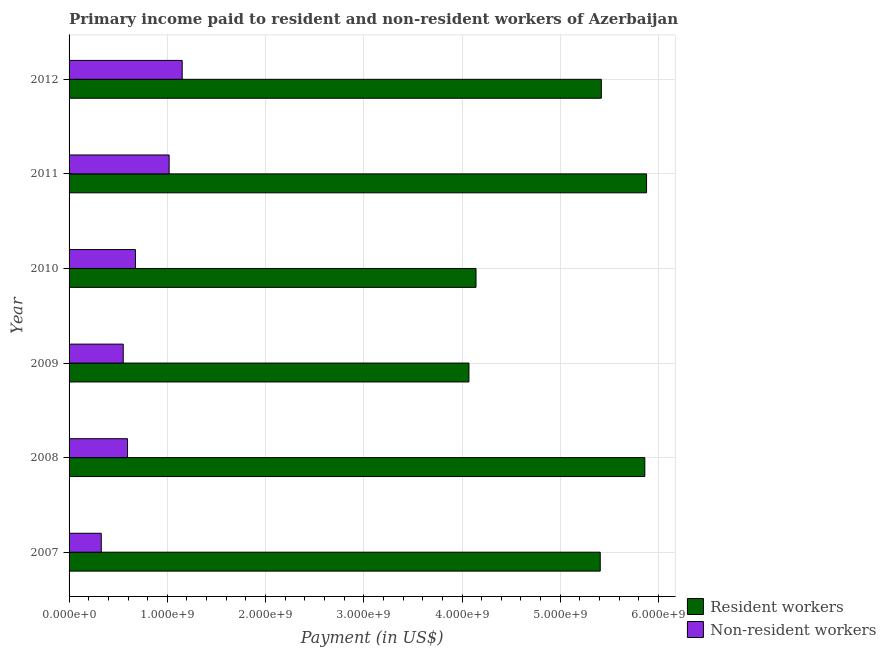How many different coloured bars are there?
Your response must be concise. 2. How many groups of bars are there?
Provide a short and direct response. 6. Are the number of bars per tick equal to the number of legend labels?
Give a very brief answer. Yes. How many bars are there on the 6th tick from the top?
Your answer should be compact. 2. How many bars are there on the 4th tick from the bottom?
Your answer should be very brief. 2. What is the label of the 6th group of bars from the top?
Keep it short and to the point. 2007. What is the payment made to resident workers in 2011?
Offer a terse response. 5.88e+09. Across all years, what is the maximum payment made to non-resident workers?
Keep it short and to the point. 1.15e+09. Across all years, what is the minimum payment made to resident workers?
Make the answer very short. 4.07e+09. In which year was the payment made to non-resident workers maximum?
Offer a very short reply. 2012. What is the total payment made to non-resident workers in the graph?
Give a very brief answer. 4.32e+09. What is the difference between the payment made to non-resident workers in 2008 and that in 2009?
Keep it short and to the point. 4.37e+07. What is the difference between the payment made to non-resident workers in 2009 and the payment made to resident workers in 2008?
Ensure brevity in your answer.  -5.31e+09. What is the average payment made to non-resident workers per year?
Provide a succinct answer. 7.20e+08. In the year 2007, what is the difference between the payment made to non-resident workers and payment made to resident workers?
Provide a short and direct response. -5.08e+09. What is the ratio of the payment made to resident workers in 2009 to that in 2012?
Offer a terse response. 0.75. What is the difference between the highest and the second highest payment made to resident workers?
Keep it short and to the point. 1.74e+07. What is the difference between the highest and the lowest payment made to non-resident workers?
Your answer should be compact. 8.24e+08. What does the 1st bar from the top in 2012 represents?
Give a very brief answer. Non-resident workers. What does the 2nd bar from the bottom in 2009 represents?
Offer a very short reply. Non-resident workers. Are all the bars in the graph horizontal?
Your response must be concise. Yes. What is the difference between two consecutive major ticks on the X-axis?
Your answer should be very brief. 1.00e+09. Are the values on the major ticks of X-axis written in scientific E-notation?
Ensure brevity in your answer.  Yes. Does the graph contain grids?
Ensure brevity in your answer.  Yes. How are the legend labels stacked?
Provide a succinct answer. Vertical. What is the title of the graph?
Your answer should be compact. Primary income paid to resident and non-resident workers of Azerbaijan. What is the label or title of the X-axis?
Offer a terse response. Payment (in US$). What is the label or title of the Y-axis?
Provide a short and direct response. Year. What is the Payment (in US$) in Resident workers in 2007?
Give a very brief answer. 5.41e+09. What is the Payment (in US$) of Non-resident workers in 2007?
Your response must be concise. 3.28e+08. What is the Payment (in US$) of Resident workers in 2008?
Ensure brevity in your answer.  5.86e+09. What is the Payment (in US$) of Non-resident workers in 2008?
Provide a short and direct response. 5.95e+08. What is the Payment (in US$) of Resident workers in 2009?
Make the answer very short. 4.07e+09. What is the Payment (in US$) of Non-resident workers in 2009?
Your answer should be very brief. 5.51e+08. What is the Payment (in US$) in Resident workers in 2010?
Provide a short and direct response. 4.14e+09. What is the Payment (in US$) of Non-resident workers in 2010?
Ensure brevity in your answer.  6.76e+08. What is the Payment (in US$) in Resident workers in 2011?
Your answer should be very brief. 5.88e+09. What is the Payment (in US$) of Non-resident workers in 2011?
Your answer should be compact. 1.02e+09. What is the Payment (in US$) of Resident workers in 2012?
Offer a terse response. 5.42e+09. What is the Payment (in US$) of Non-resident workers in 2012?
Your answer should be compact. 1.15e+09. Across all years, what is the maximum Payment (in US$) in Resident workers?
Give a very brief answer. 5.88e+09. Across all years, what is the maximum Payment (in US$) in Non-resident workers?
Your response must be concise. 1.15e+09. Across all years, what is the minimum Payment (in US$) in Resident workers?
Ensure brevity in your answer.  4.07e+09. Across all years, what is the minimum Payment (in US$) of Non-resident workers?
Keep it short and to the point. 3.28e+08. What is the total Payment (in US$) in Resident workers in the graph?
Make the answer very short. 3.08e+1. What is the total Payment (in US$) of Non-resident workers in the graph?
Your response must be concise. 4.32e+09. What is the difference between the Payment (in US$) of Resident workers in 2007 and that in 2008?
Provide a short and direct response. -4.54e+08. What is the difference between the Payment (in US$) of Non-resident workers in 2007 and that in 2008?
Make the answer very short. -2.67e+08. What is the difference between the Payment (in US$) in Resident workers in 2007 and that in 2009?
Offer a very short reply. 1.34e+09. What is the difference between the Payment (in US$) in Non-resident workers in 2007 and that in 2009?
Your answer should be very brief. -2.24e+08. What is the difference between the Payment (in US$) in Resident workers in 2007 and that in 2010?
Your answer should be very brief. 1.26e+09. What is the difference between the Payment (in US$) of Non-resident workers in 2007 and that in 2010?
Offer a very short reply. -3.48e+08. What is the difference between the Payment (in US$) of Resident workers in 2007 and that in 2011?
Provide a succinct answer. -4.71e+08. What is the difference between the Payment (in US$) of Non-resident workers in 2007 and that in 2011?
Your response must be concise. -6.91e+08. What is the difference between the Payment (in US$) of Resident workers in 2007 and that in 2012?
Make the answer very short. -1.13e+07. What is the difference between the Payment (in US$) of Non-resident workers in 2007 and that in 2012?
Offer a very short reply. -8.24e+08. What is the difference between the Payment (in US$) of Resident workers in 2008 and that in 2009?
Provide a short and direct response. 1.79e+09. What is the difference between the Payment (in US$) in Non-resident workers in 2008 and that in 2009?
Ensure brevity in your answer.  4.37e+07. What is the difference between the Payment (in US$) in Resident workers in 2008 and that in 2010?
Keep it short and to the point. 1.72e+09. What is the difference between the Payment (in US$) of Non-resident workers in 2008 and that in 2010?
Make the answer very short. -8.04e+07. What is the difference between the Payment (in US$) of Resident workers in 2008 and that in 2011?
Provide a succinct answer. -1.74e+07. What is the difference between the Payment (in US$) in Non-resident workers in 2008 and that in 2011?
Your response must be concise. -4.24e+08. What is the difference between the Payment (in US$) in Resident workers in 2008 and that in 2012?
Ensure brevity in your answer.  4.43e+08. What is the difference between the Payment (in US$) of Non-resident workers in 2008 and that in 2012?
Keep it short and to the point. -5.56e+08. What is the difference between the Payment (in US$) of Resident workers in 2009 and that in 2010?
Provide a succinct answer. -7.20e+07. What is the difference between the Payment (in US$) of Non-resident workers in 2009 and that in 2010?
Provide a short and direct response. -1.24e+08. What is the difference between the Payment (in US$) in Resident workers in 2009 and that in 2011?
Ensure brevity in your answer.  -1.81e+09. What is the difference between the Payment (in US$) in Non-resident workers in 2009 and that in 2011?
Your answer should be very brief. -4.67e+08. What is the difference between the Payment (in US$) of Resident workers in 2009 and that in 2012?
Provide a succinct answer. -1.35e+09. What is the difference between the Payment (in US$) of Non-resident workers in 2009 and that in 2012?
Ensure brevity in your answer.  -6.00e+08. What is the difference between the Payment (in US$) of Resident workers in 2010 and that in 2011?
Give a very brief answer. -1.74e+09. What is the difference between the Payment (in US$) in Non-resident workers in 2010 and that in 2011?
Make the answer very short. -3.43e+08. What is the difference between the Payment (in US$) in Resident workers in 2010 and that in 2012?
Make the answer very short. -1.28e+09. What is the difference between the Payment (in US$) of Non-resident workers in 2010 and that in 2012?
Give a very brief answer. -4.76e+08. What is the difference between the Payment (in US$) of Resident workers in 2011 and that in 2012?
Provide a short and direct response. 4.60e+08. What is the difference between the Payment (in US$) of Non-resident workers in 2011 and that in 2012?
Offer a terse response. -1.33e+08. What is the difference between the Payment (in US$) in Resident workers in 2007 and the Payment (in US$) in Non-resident workers in 2008?
Offer a very short reply. 4.81e+09. What is the difference between the Payment (in US$) in Resident workers in 2007 and the Payment (in US$) in Non-resident workers in 2009?
Your answer should be compact. 4.86e+09. What is the difference between the Payment (in US$) in Resident workers in 2007 and the Payment (in US$) in Non-resident workers in 2010?
Your answer should be very brief. 4.73e+09. What is the difference between the Payment (in US$) of Resident workers in 2007 and the Payment (in US$) of Non-resident workers in 2011?
Your response must be concise. 4.39e+09. What is the difference between the Payment (in US$) of Resident workers in 2007 and the Payment (in US$) of Non-resident workers in 2012?
Your response must be concise. 4.26e+09. What is the difference between the Payment (in US$) of Resident workers in 2008 and the Payment (in US$) of Non-resident workers in 2009?
Provide a succinct answer. 5.31e+09. What is the difference between the Payment (in US$) of Resident workers in 2008 and the Payment (in US$) of Non-resident workers in 2010?
Offer a very short reply. 5.19e+09. What is the difference between the Payment (in US$) of Resident workers in 2008 and the Payment (in US$) of Non-resident workers in 2011?
Offer a terse response. 4.84e+09. What is the difference between the Payment (in US$) in Resident workers in 2008 and the Payment (in US$) in Non-resident workers in 2012?
Make the answer very short. 4.71e+09. What is the difference between the Payment (in US$) of Resident workers in 2009 and the Payment (in US$) of Non-resident workers in 2010?
Offer a terse response. 3.40e+09. What is the difference between the Payment (in US$) in Resident workers in 2009 and the Payment (in US$) in Non-resident workers in 2011?
Make the answer very short. 3.05e+09. What is the difference between the Payment (in US$) in Resident workers in 2009 and the Payment (in US$) in Non-resident workers in 2012?
Your response must be concise. 2.92e+09. What is the difference between the Payment (in US$) of Resident workers in 2010 and the Payment (in US$) of Non-resident workers in 2011?
Offer a very short reply. 3.12e+09. What is the difference between the Payment (in US$) of Resident workers in 2010 and the Payment (in US$) of Non-resident workers in 2012?
Your answer should be compact. 2.99e+09. What is the difference between the Payment (in US$) in Resident workers in 2011 and the Payment (in US$) in Non-resident workers in 2012?
Provide a succinct answer. 4.73e+09. What is the average Payment (in US$) of Resident workers per year?
Offer a very short reply. 5.13e+09. What is the average Payment (in US$) in Non-resident workers per year?
Offer a very short reply. 7.20e+08. In the year 2007, what is the difference between the Payment (in US$) in Resident workers and Payment (in US$) in Non-resident workers?
Ensure brevity in your answer.  5.08e+09. In the year 2008, what is the difference between the Payment (in US$) of Resident workers and Payment (in US$) of Non-resident workers?
Your answer should be very brief. 5.27e+09. In the year 2009, what is the difference between the Payment (in US$) in Resident workers and Payment (in US$) in Non-resident workers?
Make the answer very short. 3.52e+09. In the year 2010, what is the difference between the Payment (in US$) of Resident workers and Payment (in US$) of Non-resident workers?
Give a very brief answer. 3.47e+09. In the year 2011, what is the difference between the Payment (in US$) in Resident workers and Payment (in US$) in Non-resident workers?
Give a very brief answer. 4.86e+09. In the year 2012, what is the difference between the Payment (in US$) of Resident workers and Payment (in US$) of Non-resident workers?
Give a very brief answer. 4.27e+09. What is the ratio of the Payment (in US$) in Resident workers in 2007 to that in 2008?
Your answer should be compact. 0.92. What is the ratio of the Payment (in US$) in Non-resident workers in 2007 to that in 2008?
Provide a short and direct response. 0.55. What is the ratio of the Payment (in US$) in Resident workers in 2007 to that in 2009?
Offer a terse response. 1.33. What is the ratio of the Payment (in US$) of Non-resident workers in 2007 to that in 2009?
Offer a terse response. 0.59. What is the ratio of the Payment (in US$) of Resident workers in 2007 to that in 2010?
Your answer should be compact. 1.31. What is the ratio of the Payment (in US$) of Non-resident workers in 2007 to that in 2010?
Your answer should be very brief. 0.49. What is the ratio of the Payment (in US$) of Resident workers in 2007 to that in 2011?
Offer a very short reply. 0.92. What is the ratio of the Payment (in US$) in Non-resident workers in 2007 to that in 2011?
Offer a very short reply. 0.32. What is the ratio of the Payment (in US$) of Resident workers in 2007 to that in 2012?
Your answer should be very brief. 1. What is the ratio of the Payment (in US$) of Non-resident workers in 2007 to that in 2012?
Make the answer very short. 0.28. What is the ratio of the Payment (in US$) in Resident workers in 2008 to that in 2009?
Make the answer very short. 1.44. What is the ratio of the Payment (in US$) in Non-resident workers in 2008 to that in 2009?
Make the answer very short. 1.08. What is the ratio of the Payment (in US$) in Resident workers in 2008 to that in 2010?
Keep it short and to the point. 1.41. What is the ratio of the Payment (in US$) in Non-resident workers in 2008 to that in 2010?
Provide a short and direct response. 0.88. What is the ratio of the Payment (in US$) in Resident workers in 2008 to that in 2011?
Your response must be concise. 1. What is the ratio of the Payment (in US$) in Non-resident workers in 2008 to that in 2011?
Your response must be concise. 0.58. What is the ratio of the Payment (in US$) of Resident workers in 2008 to that in 2012?
Your answer should be very brief. 1.08. What is the ratio of the Payment (in US$) of Non-resident workers in 2008 to that in 2012?
Give a very brief answer. 0.52. What is the ratio of the Payment (in US$) of Resident workers in 2009 to that in 2010?
Your response must be concise. 0.98. What is the ratio of the Payment (in US$) in Non-resident workers in 2009 to that in 2010?
Ensure brevity in your answer.  0.82. What is the ratio of the Payment (in US$) in Resident workers in 2009 to that in 2011?
Ensure brevity in your answer.  0.69. What is the ratio of the Payment (in US$) in Non-resident workers in 2009 to that in 2011?
Keep it short and to the point. 0.54. What is the ratio of the Payment (in US$) of Resident workers in 2009 to that in 2012?
Keep it short and to the point. 0.75. What is the ratio of the Payment (in US$) in Non-resident workers in 2009 to that in 2012?
Provide a succinct answer. 0.48. What is the ratio of the Payment (in US$) of Resident workers in 2010 to that in 2011?
Ensure brevity in your answer.  0.7. What is the ratio of the Payment (in US$) in Non-resident workers in 2010 to that in 2011?
Offer a terse response. 0.66. What is the ratio of the Payment (in US$) of Resident workers in 2010 to that in 2012?
Keep it short and to the point. 0.76. What is the ratio of the Payment (in US$) of Non-resident workers in 2010 to that in 2012?
Provide a short and direct response. 0.59. What is the ratio of the Payment (in US$) in Resident workers in 2011 to that in 2012?
Make the answer very short. 1.08. What is the ratio of the Payment (in US$) of Non-resident workers in 2011 to that in 2012?
Offer a terse response. 0.88. What is the difference between the highest and the second highest Payment (in US$) in Resident workers?
Make the answer very short. 1.74e+07. What is the difference between the highest and the second highest Payment (in US$) in Non-resident workers?
Your answer should be compact. 1.33e+08. What is the difference between the highest and the lowest Payment (in US$) in Resident workers?
Make the answer very short. 1.81e+09. What is the difference between the highest and the lowest Payment (in US$) of Non-resident workers?
Make the answer very short. 8.24e+08. 